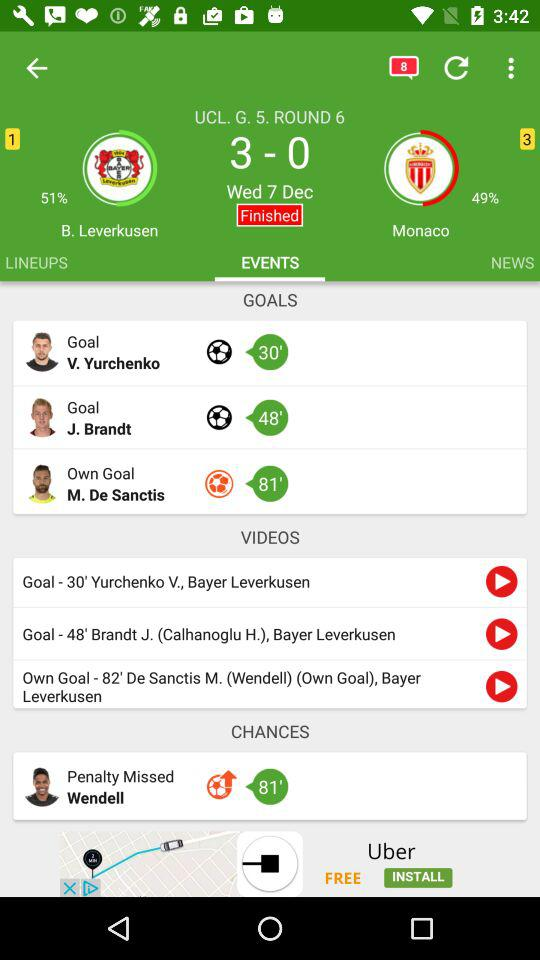On what date is the match between "B. Leverkusen" and "Monaco" played? The date is Wednesday, December 7. 